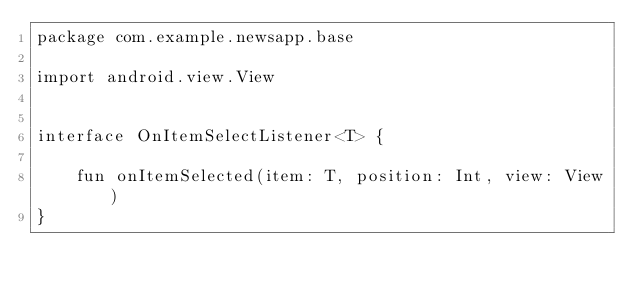Convert code to text. <code><loc_0><loc_0><loc_500><loc_500><_Kotlin_>package com.example.newsapp.base

import android.view.View


interface OnItemSelectListener<T> {

    fun onItemSelected(item: T, position: Int, view: View)
}</code> 